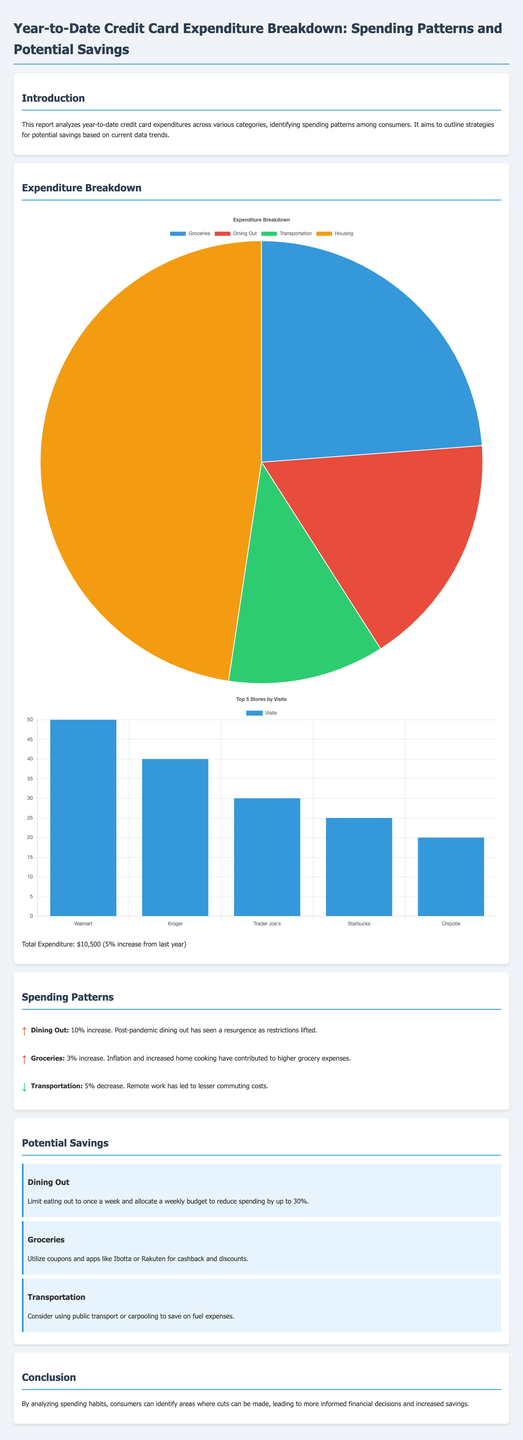What is the total expenditure? The total expenditure is stated in the document as the sum for the year-to-date credit card amounts.
Answer: $10,500 What percentage increase does the total expenditure reflect from last year? This indicates the change in total expenditure compared to previous year spending.
Answer: 5% Which category saw the highest expenditure? This category is noted to have the largest spending share in the breakdown section of the report.
Answer: Housing How much could dining out spending be reduced by with a weekly limit? The document details suggested strategies for cutting costs on dining.
Answer: 30% Which category experienced a decrease in spending? This indicates a trend of spending reduction during the year.
Answer: Transportation What are two apps recommended for grocery savings? These apps help consumers achieve cashback and discounts on grocery purchases.
Answer: Ibotta and Rakuten How many visits did Walmart receive among the top stores? This reflects shopper frequency at this top store.
Answer: 50 What was the percentage increase in spending for groceries? This percentage reflects the change in consumer spending within this category over the year.
Answer: 3% What is one strategy to save on transportation costs? This encapsulates the recommended approach for reducing transportation expenses.
Answer: Public transport or carpooling 